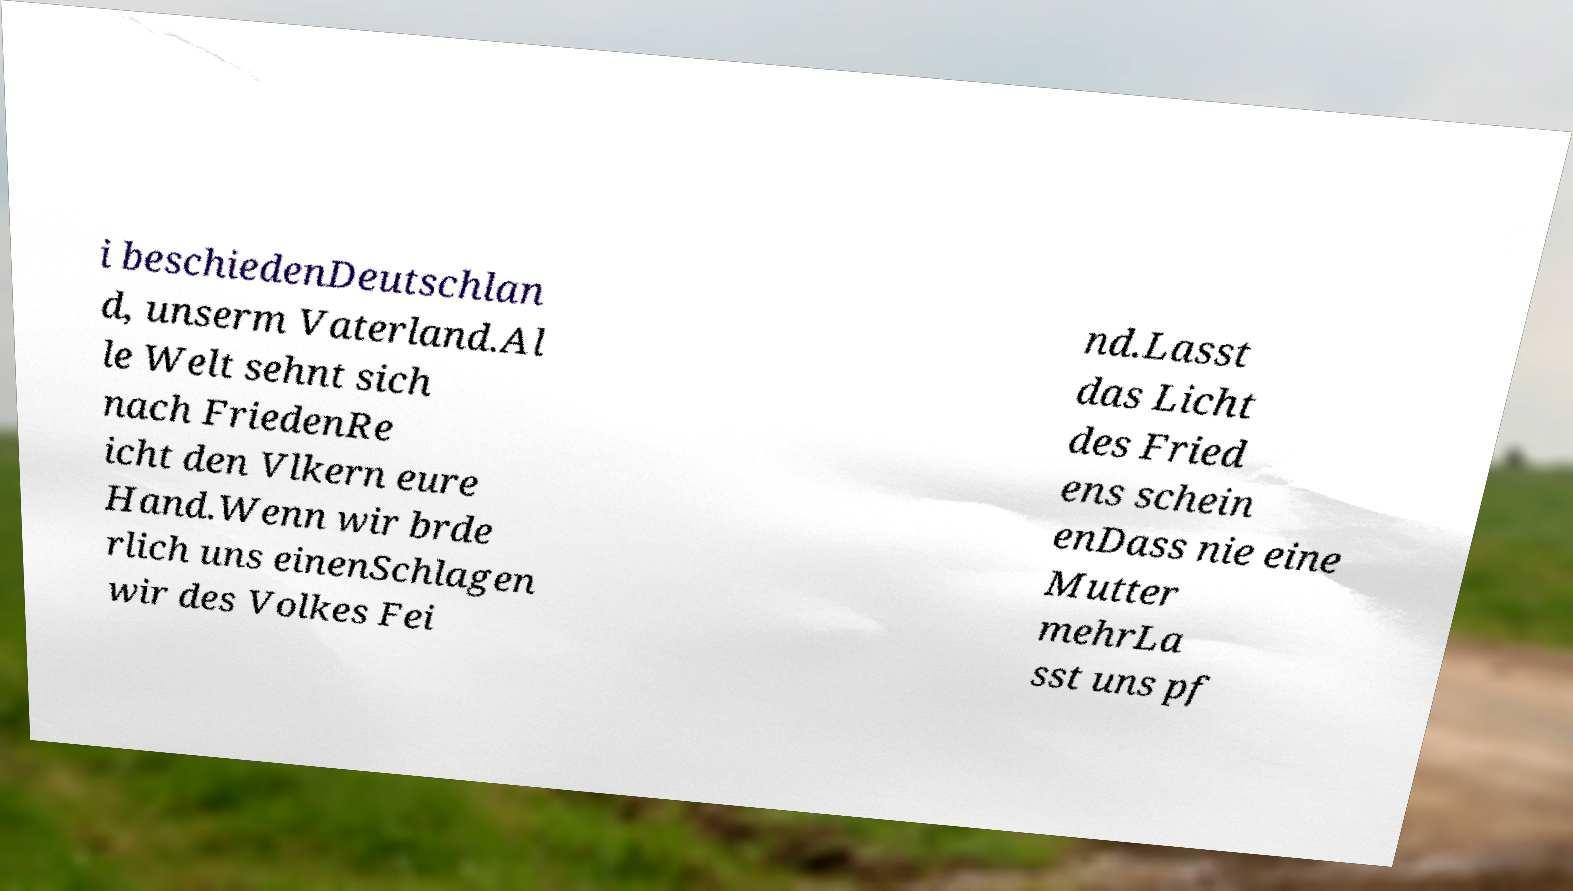There's text embedded in this image that I need extracted. Can you transcribe it verbatim? i beschiedenDeutschlan d, unserm Vaterland.Al le Welt sehnt sich nach FriedenRe icht den Vlkern eure Hand.Wenn wir brde rlich uns einenSchlagen wir des Volkes Fei nd.Lasst das Licht des Fried ens schein enDass nie eine Mutter mehrLa sst uns pf 